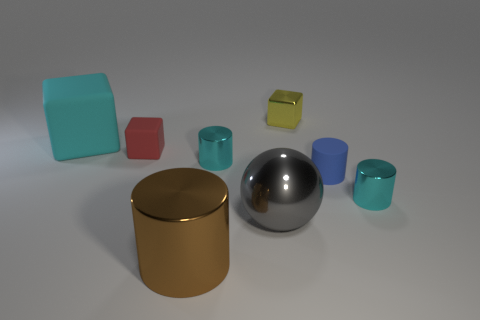Subtract all gray cylinders. Subtract all blue spheres. How many cylinders are left? 4 Add 1 blue matte blocks. How many objects exist? 9 Subtract all cubes. How many objects are left? 5 Add 3 blue matte objects. How many blue matte objects exist? 4 Subtract 0 green cylinders. How many objects are left? 8 Subtract all tiny yellow metal things. Subtract all big gray spheres. How many objects are left? 6 Add 4 cyan cubes. How many cyan cubes are left? 5 